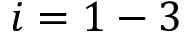Convert formula to latex. <formula><loc_0><loc_0><loc_500><loc_500>i = 1 - 3</formula> 